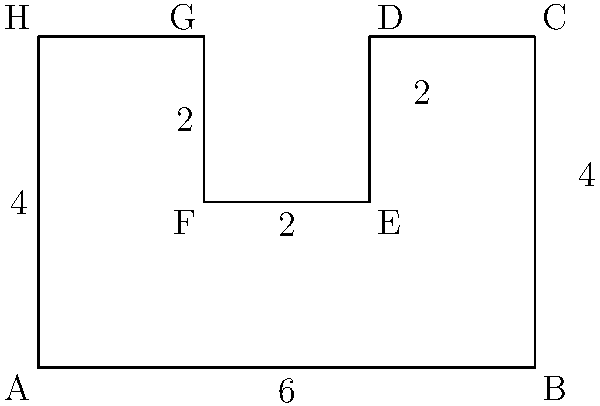As a mechatronics enthusiast, you're designing a custom robotics platform. The base plate needs to be cut from a sheet metal in the shape shown above. Calculate the perimeter of this complex shape to determine the total length of cutting required. All measurements are in centimeters. Let's break down the shape into segments and calculate the perimeter step by step:

1) Bottom edge (AB): 6 cm
2) Right edge (BC): 4 cm
3) Top-right edge (CD): 2 cm
4) Right inner edge (DE): 2 cm
5) Bottom inner edge (EF): 2 cm
6) Left inner edge (FG): 2 cm
7) Top-left edge (GH): 2 cm
8) Left edge (HA): 4 cm

To calculate the total perimeter, we sum up all these segments:

$$\text{Perimeter} = 6 + 4 + 2 + 2 + 2 + 2 + 2 + 4 = 24 \text{ cm}$$

This calculation gives us the total length of cutting required to create the base plate from sheet metal.
Answer: 24 cm 